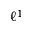<formula> <loc_0><loc_0><loc_500><loc_500>\ell ^ { 1 }</formula> 